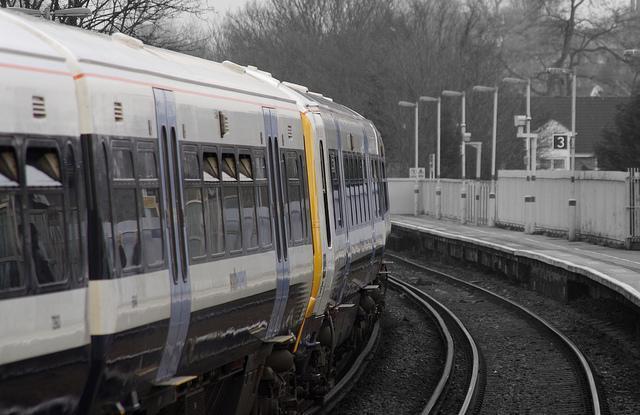How many of the train's windows are open?
Give a very brief answer. 5. How many people are touching the motorcycle?
Give a very brief answer. 0. 